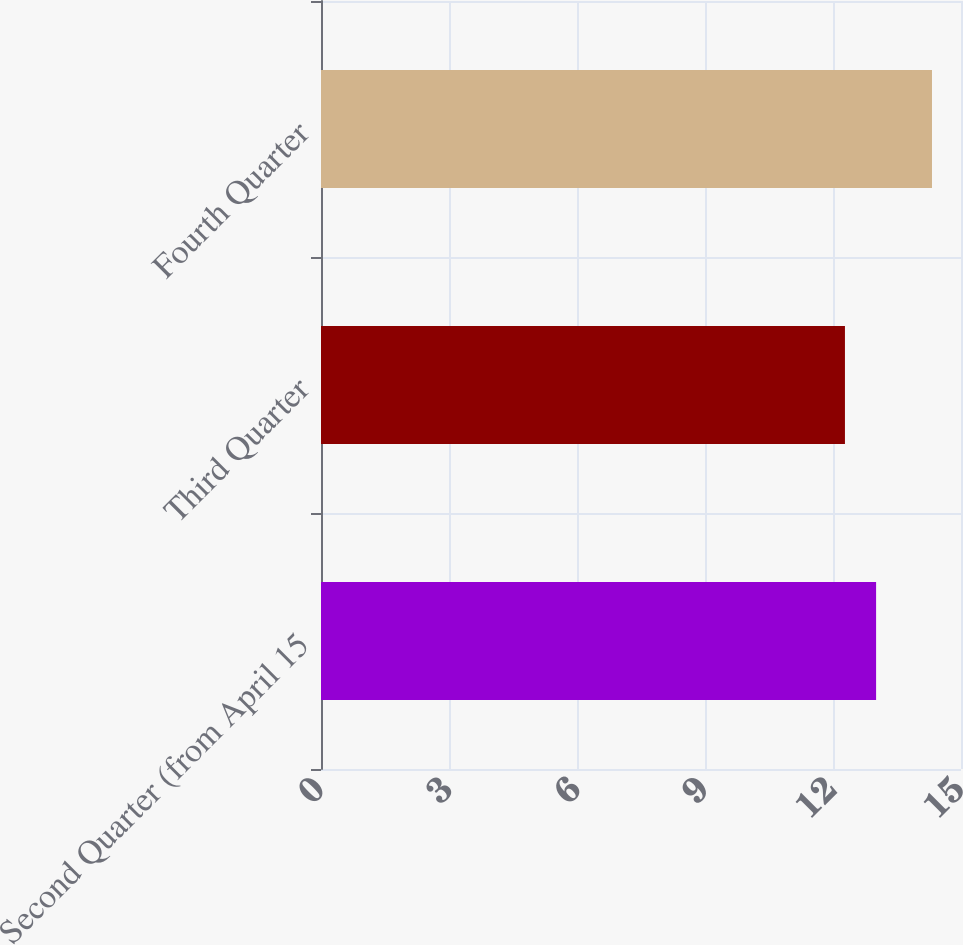<chart> <loc_0><loc_0><loc_500><loc_500><bar_chart><fcel>Second Quarter (from April 15<fcel>Third Quarter<fcel>Fourth Quarter<nl><fcel>13.01<fcel>12.28<fcel>14.32<nl></chart> 